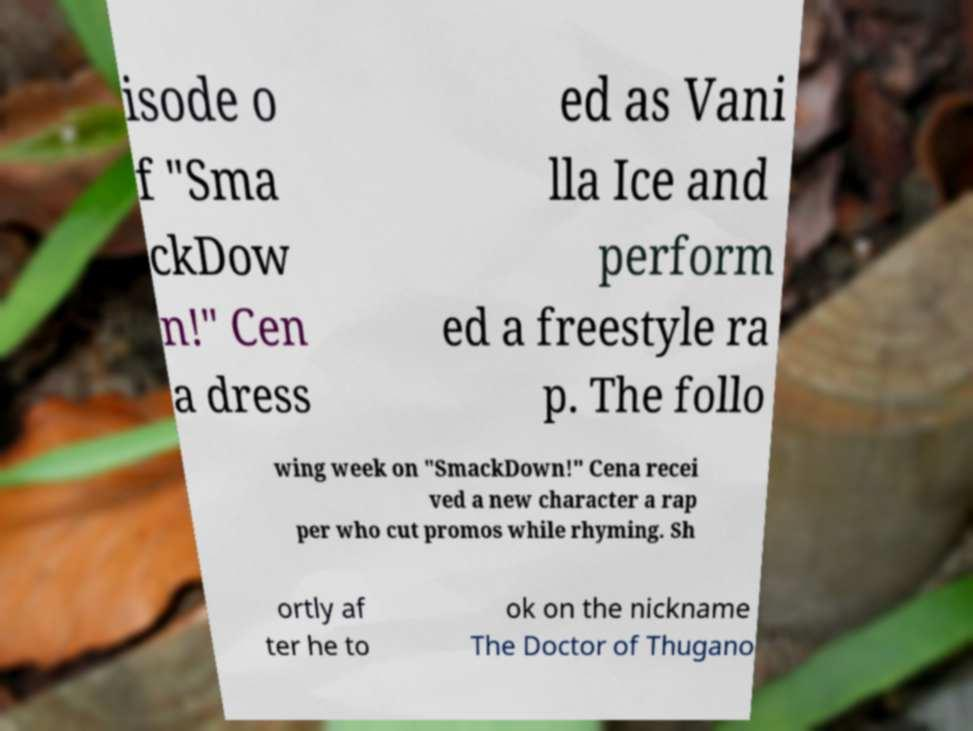What messages or text are displayed in this image? I need them in a readable, typed format. isode o f "Sma ckDow n!" Cen a dress ed as Vani lla Ice and perform ed a freestyle ra p. The follo wing week on "SmackDown!" Cena recei ved a new character a rap per who cut promos while rhyming. Sh ortly af ter he to ok on the nickname The Doctor of Thugano 